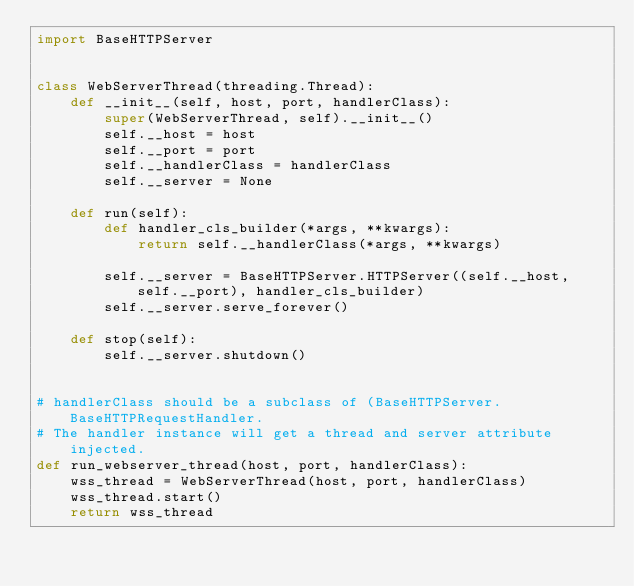<code> <loc_0><loc_0><loc_500><loc_500><_Python_>import BaseHTTPServer


class WebServerThread(threading.Thread):
    def __init__(self, host, port, handlerClass):
        super(WebServerThread, self).__init__()
        self.__host = host
        self.__port = port
        self.__handlerClass = handlerClass
        self.__server = None

    def run(self):
        def handler_cls_builder(*args, **kwargs):
            return self.__handlerClass(*args, **kwargs)

        self.__server = BaseHTTPServer.HTTPServer((self.__host, self.__port), handler_cls_builder)
        self.__server.serve_forever()

    def stop(self):
        self.__server.shutdown()


# handlerClass should be a subclass of (BaseHTTPServer.BaseHTTPRequestHandler.
# The handler instance will get a thread and server attribute injected.
def run_webserver_thread(host, port, handlerClass):
    wss_thread = WebServerThread(host, port, handlerClass)
    wss_thread.start()
    return wss_thread
</code> 